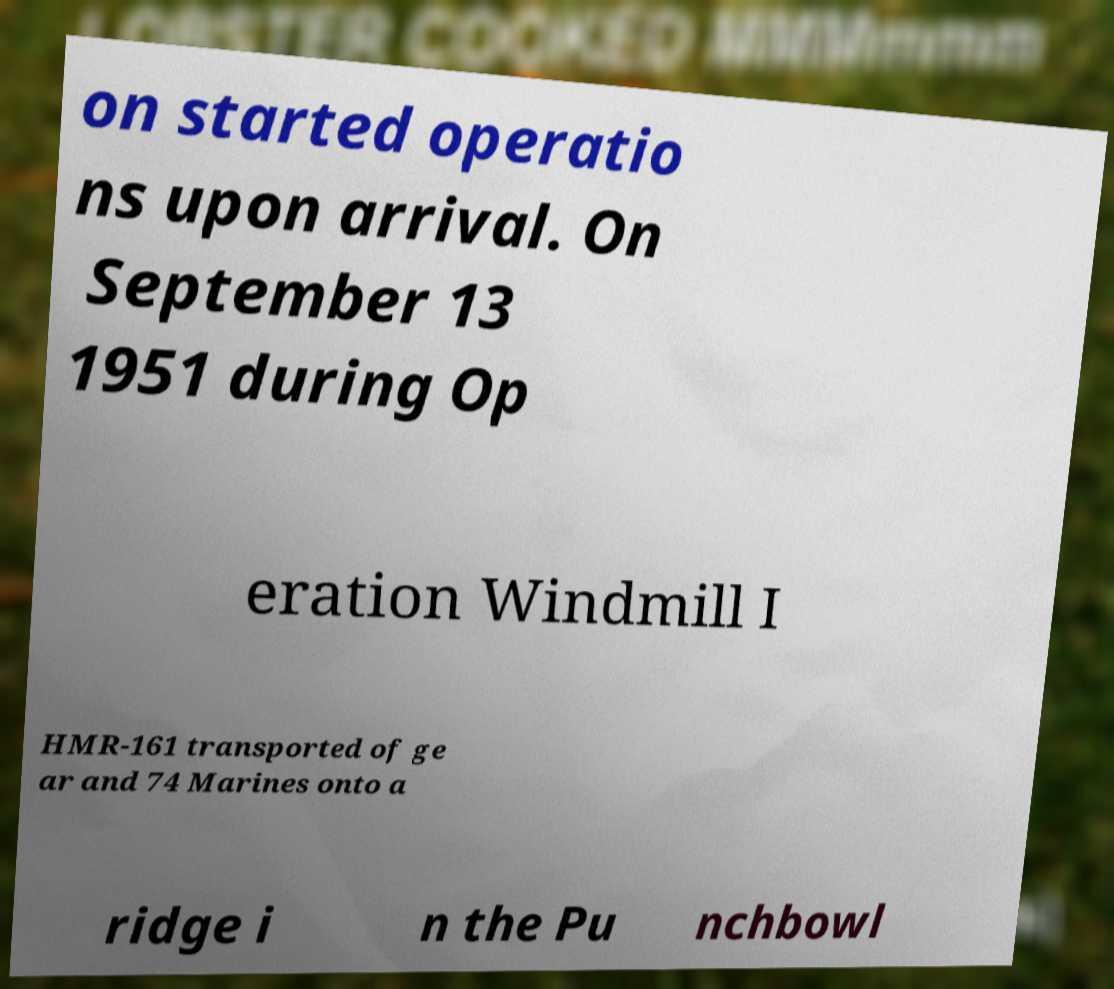Could you extract and type out the text from this image? on started operatio ns upon arrival. On September 13 1951 during Op eration Windmill I HMR-161 transported of ge ar and 74 Marines onto a ridge i n the Pu nchbowl 